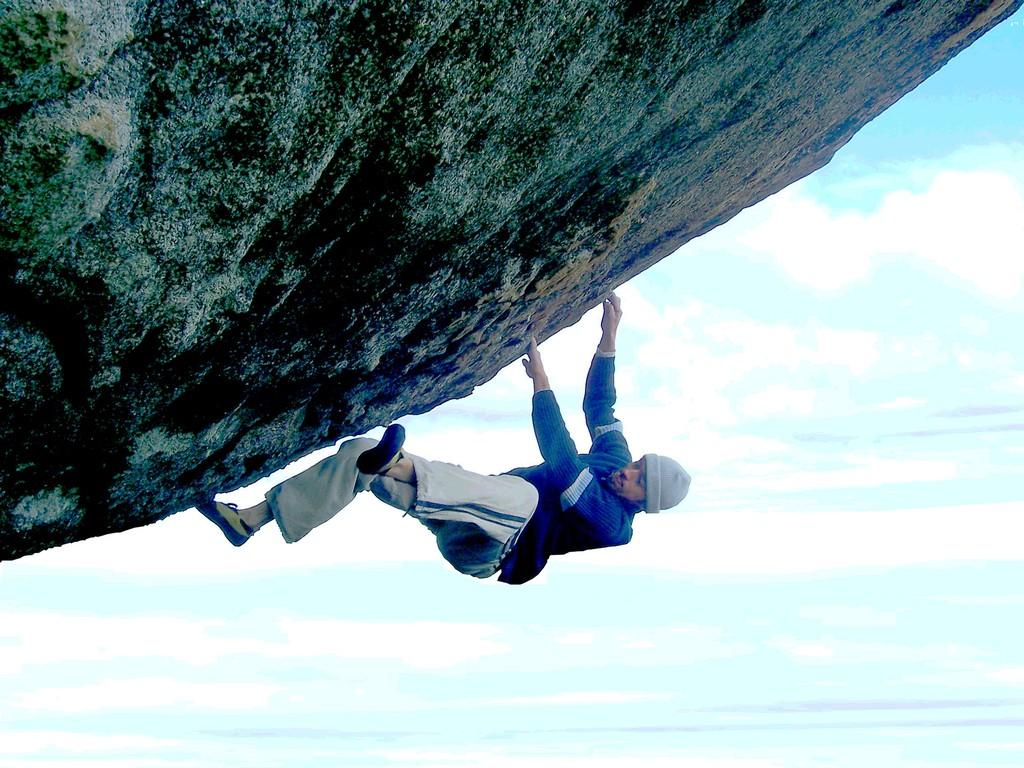What is located at the top of the image? There is a rock at the top of the image. What is the person in the image doing? A person is climbing the rock in the middle of the image. What can be seen in the sky at the bottom of the image? There are clouds visible in the sky at the bottom of the image. How many toes are visible on the chicken in the image? There is no chicken present in the image; it features a person climbing a rock and clouds in the sky. Is the milk being poured into the rock in the image? There is no milk present in the image. 